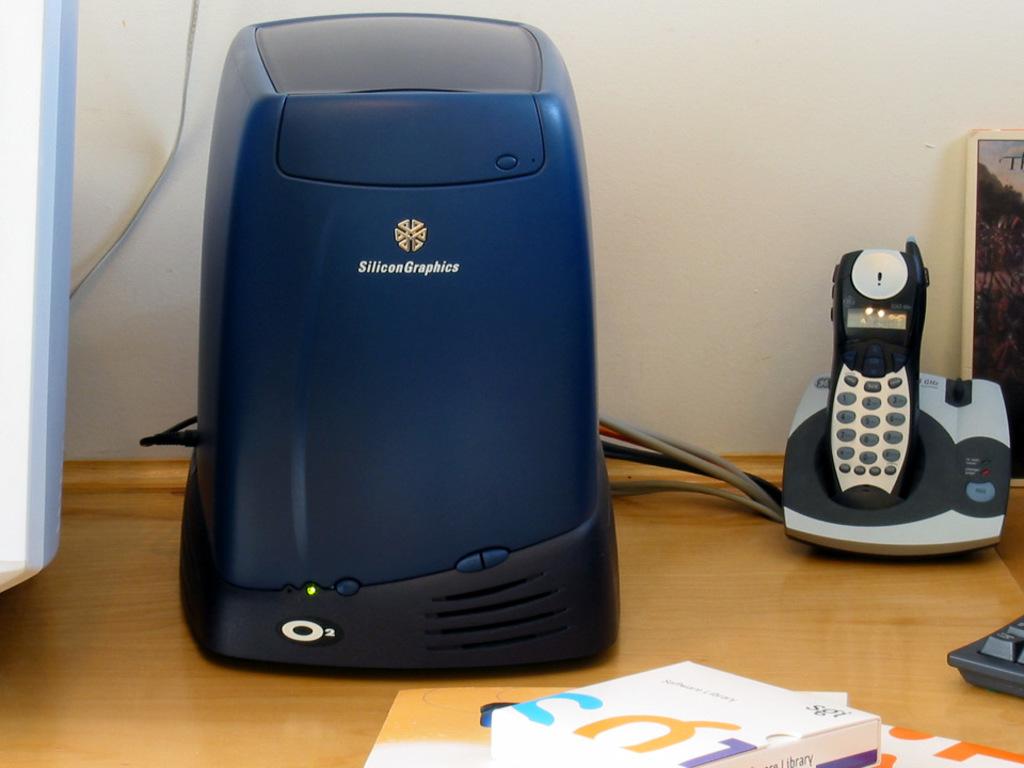What company makes the computer?
Keep it short and to the point. Unanswerable. 